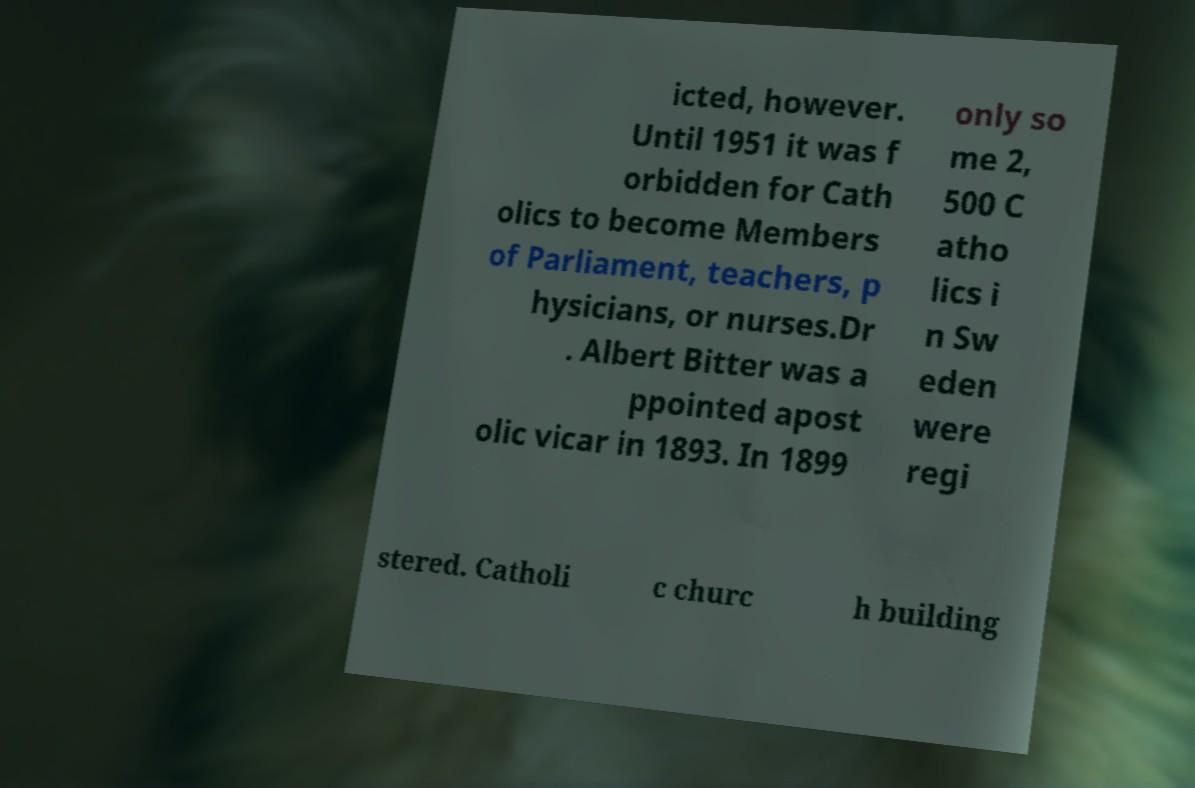Please read and relay the text visible in this image. What does it say? icted, however. Until 1951 it was f orbidden for Cath olics to become Members of Parliament, teachers, p hysicians, or nurses.Dr . Albert Bitter was a ppointed apost olic vicar in 1893. In 1899 only so me 2, 500 C atho lics i n Sw eden were regi stered. Catholi c churc h building 